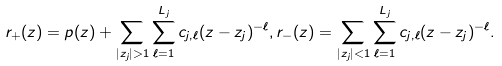<formula> <loc_0><loc_0><loc_500><loc_500>r _ { + } ( z ) = p ( z ) + \sum _ { | z _ { j } | > 1 } \sum _ { \ell = 1 } ^ { L _ { j } } c _ { j , \ell } ( z - z _ { j } ) ^ { - \ell } , r _ { - } ( z ) = \sum _ { | z _ { j } | < 1 } \sum _ { \ell = 1 } ^ { L _ { j } } c _ { j , \ell } ( z - z _ { j } ) ^ { - \ell } .</formula> 